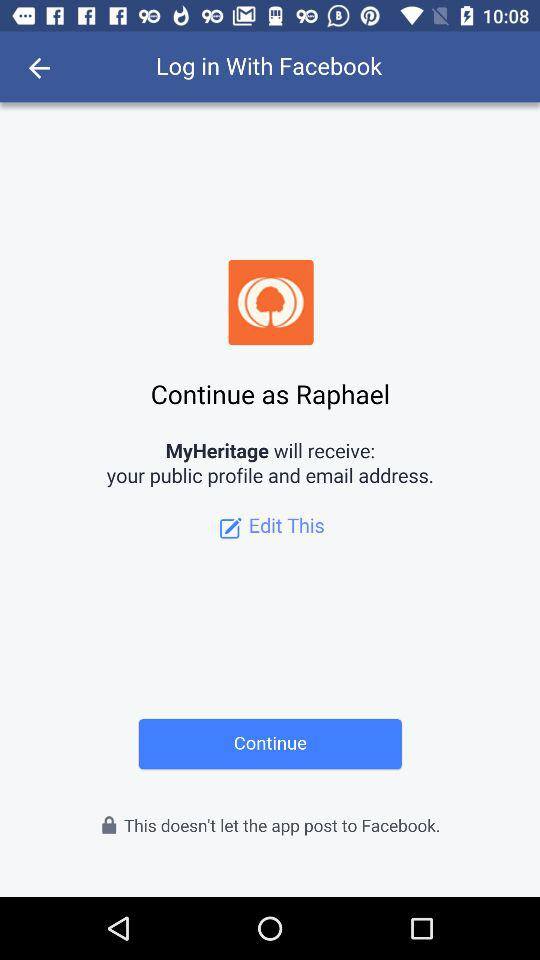Who will receive my public profile and email address? Your public profile and email address will be received by "MyHeritage". 